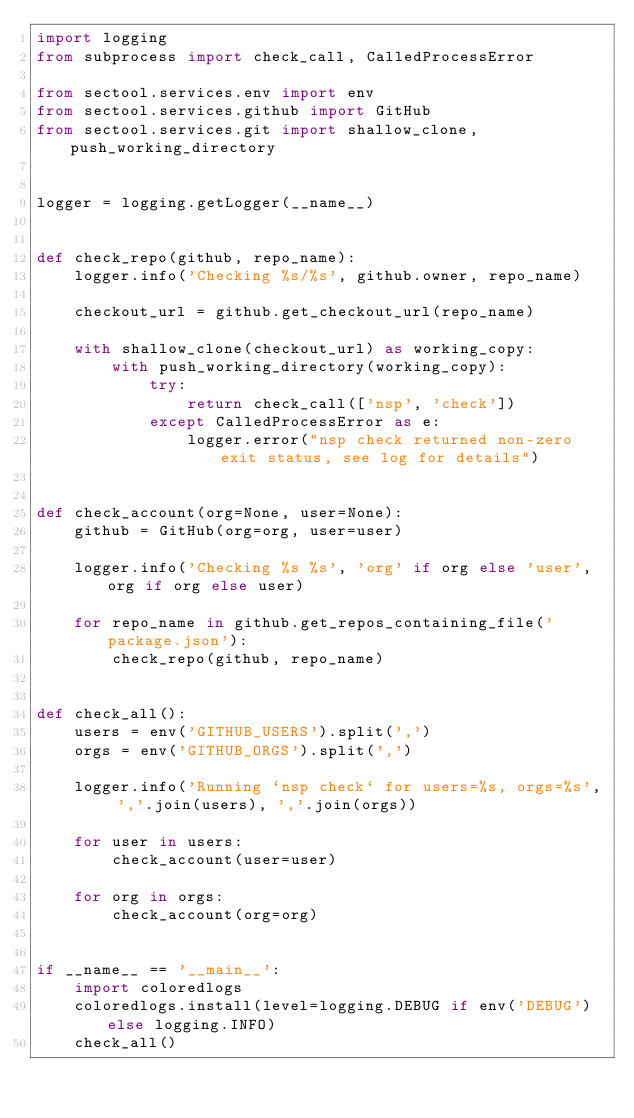<code> <loc_0><loc_0><loc_500><loc_500><_Python_>import logging
from subprocess import check_call, CalledProcessError

from sectool.services.env import env
from sectool.services.github import GitHub
from sectool.services.git import shallow_clone, push_working_directory


logger = logging.getLogger(__name__)


def check_repo(github, repo_name):
    logger.info('Checking %s/%s', github.owner, repo_name)

    checkout_url = github.get_checkout_url(repo_name)

    with shallow_clone(checkout_url) as working_copy:
        with push_working_directory(working_copy):
            try:
                return check_call(['nsp', 'check'])
            except CalledProcessError as e:
                logger.error("nsp check returned non-zero exit status, see log for details")


def check_account(org=None, user=None):
    github = GitHub(org=org, user=user)

    logger.info('Checking %s %s', 'org' if org else 'user', org if org else user)

    for repo_name in github.get_repos_containing_file('package.json'):
        check_repo(github, repo_name)


def check_all():
    users = env('GITHUB_USERS').split(',')
    orgs = env('GITHUB_ORGS').split(',')

    logger.info('Running `nsp check` for users=%s, orgs=%s', ','.join(users), ','.join(orgs))

    for user in users:
        check_account(user=user)

    for org in orgs:
        check_account(org=org)


if __name__ == '__main__':
    import coloredlogs
    coloredlogs.install(level=logging.DEBUG if env('DEBUG') else logging.INFO)
    check_all()</code> 